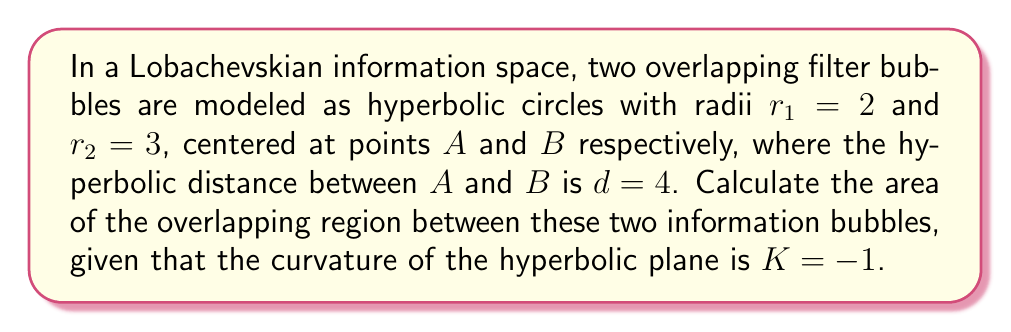Could you help me with this problem? To solve this problem, we'll follow these steps:

1) In hyperbolic geometry, the area of a circle with radius $r$ is given by:

   $$A = 4\pi \sinh^2(\frac{r}{2})$$

2) The area of overlap can be found by calculating the areas of two hyperbolic triangles and subtracting them from the sum of the two sector areas.

3) First, let's calculate the angles $\alpha$ and $\beta$ at the centers of the circles using the hyperbolic law of cosines:

   $$\cosh(d) = \cosh(r_1)\cosh(r_2) - \sinh(r_1)\sinh(r_2)\cos(\alpha + \beta)$$

4) Substituting our values:

   $$\cosh(4) = \cosh(2)\cosh(3) - \sinh(2)\sinh(3)\cos(\alpha + \beta)$$

5) Solving this equation numerically (as it's transcendental), we get:

   $$\alpha + \beta \approx 1.8849$$

6) Now we can calculate the areas of the sectors:

   $$A_{sector1} = 2\pi\sinh^2(1) \cdot \frac{\alpha}{2\pi} = \alpha\sinh^2(1)$$
   $$A_{sector2} = 2\pi\sinh^2(1.5) \cdot \frac{\beta}{2\pi} = \beta\sinh^2(1.5)$$

7) The area of a hyperbolic triangle with angles $(\theta, \phi, \psi)$ is:

   $$A_{triangle} = \pi - (\theta + \phi + \psi)$$

8) The area of overlap is:

   $$A_{overlap} = A_{sector1} + A_{sector2} - 2(\pi - (\frac{\pi}{2} + \frac{\alpha}{2} + \frac{\beta}{2}))$$

9) Substituting and calculating:

   $$A_{overlap} \approx 0.9424\sinh^2(1) + 0.9424\sinh^2(1.5) - 2(\pi - (\frac{\pi}{2} + 0.9424))$$
   $$A_{overlap} \approx 1.1479 + 3.0898 - 2(0.1992)$$
   $$A_{overlap} \approx 3.8393$$
Answer: $3.8393$ 